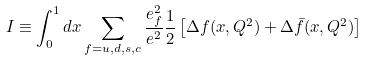<formula> <loc_0><loc_0><loc_500><loc_500>I \equiv \int _ { 0 } ^ { 1 } d x \sum _ { f = u , d , s , c } \frac { e _ { f } ^ { 2 } } { e ^ { 2 } } \frac { 1 } { 2 } \left [ \Delta { f } ( x , Q ^ { 2 } ) + \Delta { \bar { f } } ( x , Q ^ { 2 } ) \right ]</formula> 